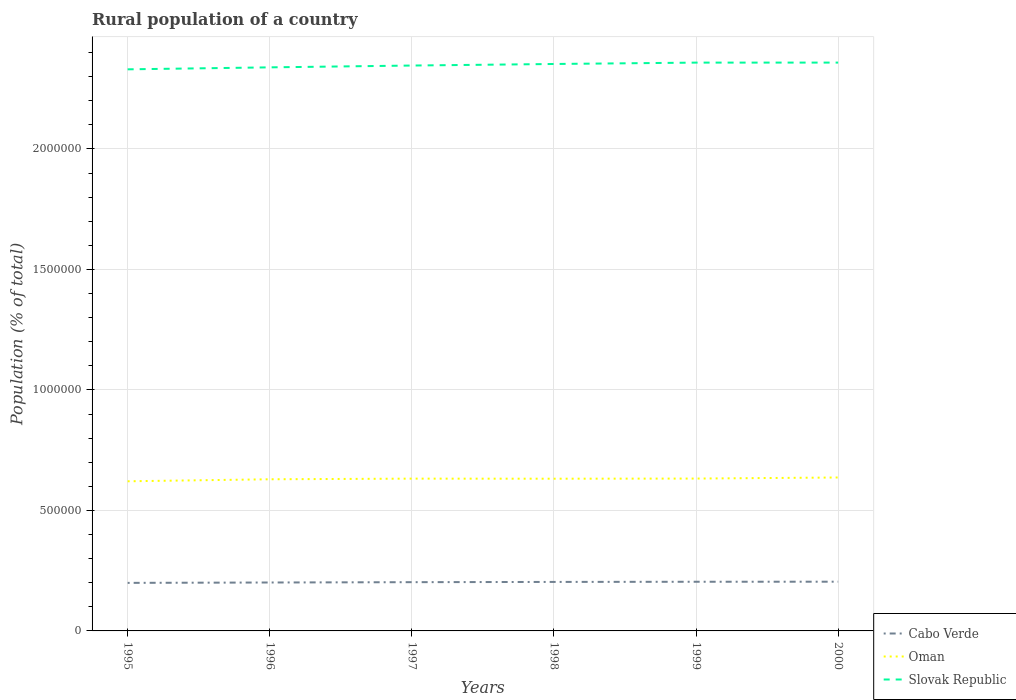Does the line corresponding to Oman intersect with the line corresponding to Cabo Verde?
Provide a succinct answer. No. Across all years, what is the maximum rural population in Cabo Verde?
Offer a terse response. 1.99e+05. What is the total rural population in Oman in the graph?
Keep it short and to the point. -4694. What is the difference between the highest and the second highest rural population in Oman?
Offer a very short reply. 1.57e+04. Is the rural population in Slovak Republic strictly greater than the rural population in Cabo Verde over the years?
Offer a very short reply. No. How many lines are there?
Your answer should be very brief. 3. How many years are there in the graph?
Ensure brevity in your answer.  6. Are the values on the major ticks of Y-axis written in scientific E-notation?
Give a very brief answer. No. Does the graph contain any zero values?
Offer a very short reply. No. How are the legend labels stacked?
Offer a very short reply. Vertical. What is the title of the graph?
Your answer should be compact. Rural population of a country. What is the label or title of the Y-axis?
Your answer should be compact. Population (% of total). What is the Population (% of total) of Cabo Verde in 1995?
Keep it short and to the point. 1.99e+05. What is the Population (% of total) in Oman in 1995?
Ensure brevity in your answer.  6.21e+05. What is the Population (% of total) of Slovak Republic in 1995?
Give a very brief answer. 2.33e+06. What is the Population (% of total) of Cabo Verde in 1996?
Offer a very short reply. 2.01e+05. What is the Population (% of total) in Oman in 1996?
Provide a short and direct response. 6.29e+05. What is the Population (% of total) in Slovak Republic in 1996?
Keep it short and to the point. 2.34e+06. What is the Population (% of total) of Cabo Verde in 1997?
Keep it short and to the point. 2.02e+05. What is the Population (% of total) in Oman in 1997?
Give a very brief answer. 6.32e+05. What is the Population (% of total) in Slovak Republic in 1997?
Offer a terse response. 2.35e+06. What is the Population (% of total) of Cabo Verde in 1998?
Your answer should be compact. 2.03e+05. What is the Population (% of total) of Oman in 1998?
Make the answer very short. 6.32e+05. What is the Population (% of total) of Slovak Republic in 1998?
Your answer should be compact. 2.35e+06. What is the Population (% of total) of Cabo Verde in 1999?
Provide a succinct answer. 2.04e+05. What is the Population (% of total) of Oman in 1999?
Your response must be concise. 6.32e+05. What is the Population (% of total) in Slovak Republic in 1999?
Offer a terse response. 2.36e+06. What is the Population (% of total) in Cabo Verde in 2000?
Offer a very short reply. 2.04e+05. What is the Population (% of total) of Oman in 2000?
Give a very brief answer. 6.37e+05. What is the Population (% of total) of Slovak Republic in 2000?
Provide a succinct answer. 2.36e+06. Across all years, what is the maximum Population (% of total) in Cabo Verde?
Give a very brief answer. 2.04e+05. Across all years, what is the maximum Population (% of total) of Oman?
Give a very brief answer. 6.37e+05. Across all years, what is the maximum Population (% of total) in Slovak Republic?
Offer a very short reply. 2.36e+06. Across all years, what is the minimum Population (% of total) of Cabo Verde?
Keep it short and to the point. 1.99e+05. Across all years, what is the minimum Population (% of total) in Oman?
Provide a short and direct response. 6.21e+05. Across all years, what is the minimum Population (% of total) in Slovak Republic?
Your response must be concise. 2.33e+06. What is the total Population (% of total) of Cabo Verde in the graph?
Provide a succinct answer. 1.21e+06. What is the total Population (% of total) of Oman in the graph?
Provide a succinct answer. 3.78e+06. What is the total Population (% of total) of Slovak Republic in the graph?
Offer a terse response. 1.41e+07. What is the difference between the Population (% of total) of Cabo Verde in 1995 and that in 1996?
Offer a very short reply. -1565. What is the difference between the Population (% of total) of Oman in 1995 and that in 1996?
Provide a short and direct response. -8349. What is the difference between the Population (% of total) in Slovak Republic in 1995 and that in 1996?
Offer a very short reply. -8216. What is the difference between the Population (% of total) in Cabo Verde in 1995 and that in 1997?
Keep it short and to the point. -2920. What is the difference between the Population (% of total) in Oman in 1995 and that in 1997?
Give a very brief answer. -1.10e+04. What is the difference between the Population (% of total) in Slovak Republic in 1995 and that in 1997?
Your answer should be very brief. -1.58e+04. What is the difference between the Population (% of total) of Cabo Verde in 1995 and that in 1998?
Keep it short and to the point. -3969. What is the difference between the Population (% of total) in Oman in 1995 and that in 1998?
Provide a succinct answer. -1.07e+04. What is the difference between the Population (% of total) of Slovak Republic in 1995 and that in 1998?
Offer a very short reply. -2.22e+04. What is the difference between the Population (% of total) in Cabo Verde in 1995 and that in 1999?
Offer a terse response. -4655. What is the difference between the Population (% of total) of Oman in 1995 and that in 1999?
Make the answer very short. -1.13e+04. What is the difference between the Population (% of total) of Slovak Republic in 1995 and that in 1999?
Keep it short and to the point. -2.79e+04. What is the difference between the Population (% of total) of Cabo Verde in 1995 and that in 2000?
Ensure brevity in your answer.  -4926. What is the difference between the Population (% of total) in Oman in 1995 and that in 2000?
Offer a terse response. -1.57e+04. What is the difference between the Population (% of total) of Slovak Republic in 1995 and that in 2000?
Provide a short and direct response. -2.80e+04. What is the difference between the Population (% of total) of Cabo Verde in 1996 and that in 1997?
Ensure brevity in your answer.  -1355. What is the difference between the Population (% of total) of Oman in 1996 and that in 1997?
Give a very brief answer. -2665. What is the difference between the Population (% of total) in Slovak Republic in 1996 and that in 1997?
Ensure brevity in your answer.  -7552. What is the difference between the Population (% of total) in Cabo Verde in 1996 and that in 1998?
Make the answer very short. -2404. What is the difference between the Population (% of total) of Oman in 1996 and that in 1998?
Give a very brief answer. -2352. What is the difference between the Population (% of total) of Slovak Republic in 1996 and that in 1998?
Offer a very short reply. -1.40e+04. What is the difference between the Population (% of total) of Cabo Verde in 1996 and that in 1999?
Your response must be concise. -3090. What is the difference between the Population (% of total) of Oman in 1996 and that in 1999?
Give a very brief answer. -2955. What is the difference between the Population (% of total) in Slovak Republic in 1996 and that in 1999?
Provide a succinct answer. -1.97e+04. What is the difference between the Population (% of total) in Cabo Verde in 1996 and that in 2000?
Your answer should be compact. -3361. What is the difference between the Population (% of total) in Oman in 1996 and that in 2000?
Provide a short and direct response. -7359. What is the difference between the Population (% of total) in Slovak Republic in 1996 and that in 2000?
Ensure brevity in your answer.  -1.98e+04. What is the difference between the Population (% of total) in Cabo Verde in 1997 and that in 1998?
Keep it short and to the point. -1049. What is the difference between the Population (% of total) in Oman in 1997 and that in 1998?
Ensure brevity in your answer.  313. What is the difference between the Population (% of total) of Slovak Republic in 1997 and that in 1998?
Provide a short and direct response. -6437. What is the difference between the Population (% of total) in Cabo Verde in 1997 and that in 1999?
Provide a succinct answer. -1735. What is the difference between the Population (% of total) of Oman in 1997 and that in 1999?
Your response must be concise. -290. What is the difference between the Population (% of total) in Slovak Republic in 1997 and that in 1999?
Your answer should be very brief. -1.21e+04. What is the difference between the Population (% of total) in Cabo Verde in 1997 and that in 2000?
Your response must be concise. -2006. What is the difference between the Population (% of total) in Oman in 1997 and that in 2000?
Provide a succinct answer. -4694. What is the difference between the Population (% of total) of Slovak Republic in 1997 and that in 2000?
Make the answer very short. -1.22e+04. What is the difference between the Population (% of total) of Cabo Verde in 1998 and that in 1999?
Offer a terse response. -686. What is the difference between the Population (% of total) in Oman in 1998 and that in 1999?
Make the answer very short. -603. What is the difference between the Population (% of total) in Slovak Republic in 1998 and that in 1999?
Your answer should be compact. -5694. What is the difference between the Population (% of total) of Cabo Verde in 1998 and that in 2000?
Your response must be concise. -957. What is the difference between the Population (% of total) of Oman in 1998 and that in 2000?
Offer a very short reply. -5007. What is the difference between the Population (% of total) of Slovak Republic in 1998 and that in 2000?
Your response must be concise. -5790. What is the difference between the Population (% of total) in Cabo Verde in 1999 and that in 2000?
Give a very brief answer. -271. What is the difference between the Population (% of total) in Oman in 1999 and that in 2000?
Make the answer very short. -4404. What is the difference between the Population (% of total) in Slovak Republic in 1999 and that in 2000?
Provide a succinct answer. -96. What is the difference between the Population (% of total) of Cabo Verde in 1995 and the Population (% of total) of Oman in 1996?
Keep it short and to the point. -4.30e+05. What is the difference between the Population (% of total) of Cabo Verde in 1995 and the Population (% of total) of Slovak Republic in 1996?
Give a very brief answer. -2.14e+06. What is the difference between the Population (% of total) in Oman in 1995 and the Population (% of total) in Slovak Republic in 1996?
Your answer should be compact. -1.72e+06. What is the difference between the Population (% of total) in Cabo Verde in 1995 and the Population (% of total) in Oman in 1997?
Provide a succinct answer. -4.33e+05. What is the difference between the Population (% of total) in Cabo Verde in 1995 and the Population (% of total) in Slovak Republic in 1997?
Provide a succinct answer. -2.15e+06. What is the difference between the Population (% of total) in Oman in 1995 and the Population (% of total) in Slovak Republic in 1997?
Offer a very short reply. -1.73e+06. What is the difference between the Population (% of total) in Cabo Verde in 1995 and the Population (% of total) in Oman in 1998?
Keep it short and to the point. -4.32e+05. What is the difference between the Population (% of total) in Cabo Verde in 1995 and the Population (% of total) in Slovak Republic in 1998?
Offer a very short reply. -2.15e+06. What is the difference between the Population (% of total) of Oman in 1995 and the Population (% of total) of Slovak Republic in 1998?
Offer a terse response. -1.73e+06. What is the difference between the Population (% of total) of Cabo Verde in 1995 and the Population (% of total) of Oman in 1999?
Provide a succinct answer. -4.33e+05. What is the difference between the Population (% of total) of Cabo Verde in 1995 and the Population (% of total) of Slovak Republic in 1999?
Ensure brevity in your answer.  -2.16e+06. What is the difference between the Population (% of total) of Oman in 1995 and the Population (% of total) of Slovak Republic in 1999?
Your response must be concise. -1.74e+06. What is the difference between the Population (% of total) in Cabo Verde in 1995 and the Population (% of total) in Oman in 2000?
Your answer should be very brief. -4.37e+05. What is the difference between the Population (% of total) of Cabo Verde in 1995 and the Population (% of total) of Slovak Republic in 2000?
Give a very brief answer. -2.16e+06. What is the difference between the Population (% of total) in Oman in 1995 and the Population (% of total) in Slovak Republic in 2000?
Your answer should be very brief. -1.74e+06. What is the difference between the Population (% of total) of Cabo Verde in 1996 and the Population (% of total) of Oman in 1997?
Make the answer very short. -4.31e+05. What is the difference between the Population (% of total) of Cabo Verde in 1996 and the Population (% of total) of Slovak Republic in 1997?
Your answer should be compact. -2.15e+06. What is the difference between the Population (% of total) of Oman in 1996 and the Population (% of total) of Slovak Republic in 1997?
Keep it short and to the point. -1.72e+06. What is the difference between the Population (% of total) of Cabo Verde in 1996 and the Population (% of total) of Oman in 1998?
Your answer should be compact. -4.31e+05. What is the difference between the Population (% of total) of Cabo Verde in 1996 and the Population (% of total) of Slovak Republic in 1998?
Give a very brief answer. -2.15e+06. What is the difference between the Population (% of total) in Oman in 1996 and the Population (% of total) in Slovak Republic in 1998?
Give a very brief answer. -1.72e+06. What is the difference between the Population (% of total) of Cabo Verde in 1996 and the Population (% of total) of Oman in 1999?
Ensure brevity in your answer.  -4.31e+05. What is the difference between the Population (% of total) in Cabo Verde in 1996 and the Population (% of total) in Slovak Republic in 1999?
Ensure brevity in your answer.  -2.16e+06. What is the difference between the Population (% of total) of Oman in 1996 and the Population (% of total) of Slovak Republic in 1999?
Offer a very short reply. -1.73e+06. What is the difference between the Population (% of total) of Cabo Verde in 1996 and the Population (% of total) of Oman in 2000?
Your answer should be compact. -4.36e+05. What is the difference between the Population (% of total) of Cabo Verde in 1996 and the Population (% of total) of Slovak Republic in 2000?
Your response must be concise. -2.16e+06. What is the difference between the Population (% of total) in Oman in 1996 and the Population (% of total) in Slovak Republic in 2000?
Provide a succinct answer. -1.73e+06. What is the difference between the Population (% of total) in Cabo Verde in 1997 and the Population (% of total) in Oman in 1998?
Offer a terse response. -4.29e+05. What is the difference between the Population (% of total) in Cabo Verde in 1997 and the Population (% of total) in Slovak Republic in 1998?
Give a very brief answer. -2.15e+06. What is the difference between the Population (% of total) of Oman in 1997 and the Population (% of total) of Slovak Republic in 1998?
Your answer should be very brief. -1.72e+06. What is the difference between the Population (% of total) in Cabo Verde in 1997 and the Population (% of total) in Oman in 1999?
Provide a short and direct response. -4.30e+05. What is the difference between the Population (% of total) in Cabo Verde in 1997 and the Population (% of total) in Slovak Republic in 1999?
Make the answer very short. -2.16e+06. What is the difference between the Population (% of total) of Oman in 1997 and the Population (% of total) of Slovak Republic in 1999?
Your response must be concise. -1.73e+06. What is the difference between the Population (% of total) of Cabo Verde in 1997 and the Population (% of total) of Oman in 2000?
Offer a terse response. -4.34e+05. What is the difference between the Population (% of total) in Cabo Verde in 1997 and the Population (% of total) in Slovak Republic in 2000?
Your response must be concise. -2.16e+06. What is the difference between the Population (% of total) of Oman in 1997 and the Population (% of total) of Slovak Republic in 2000?
Offer a very short reply. -1.73e+06. What is the difference between the Population (% of total) of Cabo Verde in 1998 and the Population (% of total) of Oman in 1999?
Give a very brief answer. -4.29e+05. What is the difference between the Population (% of total) in Cabo Verde in 1998 and the Population (% of total) in Slovak Republic in 1999?
Provide a short and direct response. -2.16e+06. What is the difference between the Population (% of total) of Oman in 1998 and the Population (% of total) of Slovak Republic in 1999?
Make the answer very short. -1.73e+06. What is the difference between the Population (% of total) in Cabo Verde in 1998 and the Population (% of total) in Oman in 2000?
Keep it short and to the point. -4.33e+05. What is the difference between the Population (% of total) of Cabo Verde in 1998 and the Population (% of total) of Slovak Republic in 2000?
Your answer should be very brief. -2.16e+06. What is the difference between the Population (% of total) in Oman in 1998 and the Population (% of total) in Slovak Republic in 2000?
Ensure brevity in your answer.  -1.73e+06. What is the difference between the Population (% of total) of Cabo Verde in 1999 and the Population (% of total) of Oman in 2000?
Offer a terse response. -4.33e+05. What is the difference between the Population (% of total) in Cabo Verde in 1999 and the Population (% of total) in Slovak Republic in 2000?
Your answer should be very brief. -2.15e+06. What is the difference between the Population (% of total) of Oman in 1999 and the Population (% of total) of Slovak Republic in 2000?
Give a very brief answer. -1.73e+06. What is the average Population (% of total) in Cabo Verde per year?
Provide a short and direct response. 2.02e+05. What is the average Population (% of total) of Oman per year?
Offer a very short reply. 6.30e+05. What is the average Population (% of total) of Slovak Republic per year?
Your answer should be compact. 2.35e+06. In the year 1995, what is the difference between the Population (% of total) of Cabo Verde and Population (% of total) of Oman?
Ensure brevity in your answer.  -4.22e+05. In the year 1995, what is the difference between the Population (% of total) of Cabo Verde and Population (% of total) of Slovak Republic?
Provide a short and direct response. -2.13e+06. In the year 1995, what is the difference between the Population (% of total) in Oman and Population (% of total) in Slovak Republic?
Keep it short and to the point. -1.71e+06. In the year 1996, what is the difference between the Population (% of total) in Cabo Verde and Population (% of total) in Oman?
Provide a short and direct response. -4.28e+05. In the year 1996, what is the difference between the Population (% of total) in Cabo Verde and Population (% of total) in Slovak Republic?
Offer a terse response. -2.14e+06. In the year 1996, what is the difference between the Population (% of total) of Oman and Population (% of total) of Slovak Republic?
Provide a short and direct response. -1.71e+06. In the year 1997, what is the difference between the Population (% of total) of Cabo Verde and Population (% of total) of Oman?
Ensure brevity in your answer.  -4.30e+05. In the year 1997, what is the difference between the Population (% of total) of Cabo Verde and Population (% of total) of Slovak Republic?
Ensure brevity in your answer.  -2.14e+06. In the year 1997, what is the difference between the Population (% of total) of Oman and Population (% of total) of Slovak Republic?
Give a very brief answer. -1.71e+06. In the year 1998, what is the difference between the Population (% of total) of Cabo Verde and Population (% of total) of Oman?
Provide a short and direct response. -4.28e+05. In the year 1998, what is the difference between the Population (% of total) in Cabo Verde and Population (% of total) in Slovak Republic?
Offer a very short reply. -2.15e+06. In the year 1998, what is the difference between the Population (% of total) in Oman and Population (% of total) in Slovak Republic?
Keep it short and to the point. -1.72e+06. In the year 1999, what is the difference between the Population (% of total) of Cabo Verde and Population (% of total) of Oman?
Your response must be concise. -4.28e+05. In the year 1999, what is the difference between the Population (% of total) in Cabo Verde and Population (% of total) in Slovak Republic?
Your response must be concise. -2.15e+06. In the year 1999, what is the difference between the Population (% of total) in Oman and Population (% of total) in Slovak Republic?
Ensure brevity in your answer.  -1.73e+06. In the year 2000, what is the difference between the Population (% of total) in Cabo Verde and Population (% of total) in Oman?
Offer a very short reply. -4.32e+05. In the year 2000, what is the difference between the Population (% of total) in Cabo Verde and Population (% of total) in Slovak Republic?
Offer a terse response. -2.15e+06. In the year 2000, what is the difference between the Population (% of total) in Oman and Population (% of total) in Slovak Republic?
Offer a very short reply. -1.72e+06. What is the ratio of the Population (% of total) in Cabo Verde in 1995 to that in 1996?
Your answer should be very brief. 0.99. What is the ratio of the Population (% of total) in Oman in 1995 to that in 1996?
Keep it short and to the point. 0.99. What is the ratio of the Population (% of total) in Cabo Verde in 1995 to that in 1997?
Keep it short and to the point. 0.99. What is the ratio of the Population (% of total) in Oman in 1995 to that in 1997?
Make the answer very short. 0.98. What is the ratio of the Population (% of total) in Cabo Verde in 1995 to that in 1998?
Offer a very short reply. 0.98. What is the ratio of the Population (% of total) of Oman in 1995 to that in 1998?
Offer a very short reply. 0.98. What is the ratio of the Population (% of total) of Slovak Republic in 1995 to that in 1998?
Your answer should be very brief. 0.99. What is the ratio of the Population (% of total) of Cabo Verde in 1995 to that in 1999?
Provide a short and direct response. 0.98. What is the ratio of the Population (% of total) of Oman in 1995 to that in 1999?
Ensure brevity in your answer.  0.98. What is the ratio of the Population (% of total) in Cabo Verde in 1995 to that in 2000?
Your answer should be compact. 0.98. What is the ratio of the Population (% of total) of Oman in 1995 to that in 2000?
Give a very brief answer. 0.98. What is the ratio of the Population (% of total) in Slovak Republic in 1995 to that in 2000?
Your answer should be very brief. 0.99. What is the ratio of the Population (% of total) of Slovak Republic in 1996 to that in 1998?
Give a very brief answer. 0.99. What is the ratio of the Population (% of total) in Cabo Verde in 1996 to that in 1999?
Your answer should be compact. 0.98. What is the ratio of the Population (% of total) of Oman in 1996 to that in 1999?
Offer a terse response. 1. What is the ratio of the Population (% of total) of Cabo Verde in 1996 to that in 2000?
Provide a short and direct response. 0.98. What is the ratio of the Population (% of total) of Oman in 1996 to that in 2000?
Your answer should be compact. 0.99. What is the ratio of the Population (% of total) in Cabo Verde in 1997 to that in 1998?
Your answer should be very brief. 0.99. What is the ratio of the Population (% of total) in Oman in 1997 to that in 1998?
Your answer should be very brief. 1. What is the ratio of the Population (% of total) of Slovak Republic in 1997 to that in 1998?
Offer a very short reply. 1. What is the ratio of the Population (% of total) of Cabo Verde in 1997 to that in 2000?
Your answer should be compact. 0.99. What is the ratio of the Population (% of total) in Slovak Republic in 1997 to that in 2000?
Keep it short and to the point. 0.99. What is the ratio of the Population (% of total) of Oman in 1998 to that in 1999?
Give a very brief answer. 1. What is the ratio of the Population (% of total) in Cabo Verde in 1998 to that in 2000?
Make the answer very short. 1. What is the ratio of the Population (% of total) in Cabo Verde in 1999 to that in 2000?
Provide a succinct answer. 1. What is the ratio of the Population (% of total) in Slovak Republic in 1999 to that in 2000?
Provide a succinct answer. 1. What is the difference between the highest and the second highest Population (% of total) in Cabo Verde?
Ensure brevity in your answer.  271. What is the difference between the highest and the second highest Population (% of total) in Oman?
Keep it short and to the point. 4404. What is the difference between the highest and the second highest Population (% of total) of Slovak Republic?
Give a very brief answer. 96. What is the difference between the highest and the lowest Population (% of total) of Cabo Verde?
Your answer should be very brief. 4926. What is the difference between the highest and the lowest Population (% of total) of Oman?
Your response must be concise. 1.57e+04. What is the difference between the highest and the lowest Population (% of total) of Slovak Republic?
Ensure brevity in your answer.  2.80e+04. 